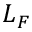Convert formula to latex. <formula><loc_0><loc_0><loc_500><loc_500>L _ { F }</formula> 